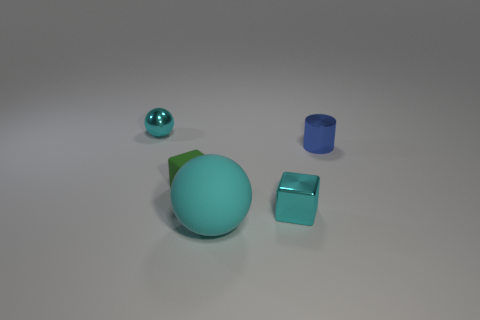Add 1 large cyan spheres. How many objects exist? 6 Subtract all balls. How many objects are left? 3 Subtract 1 cubes. How many cubes are left? 1 Subtract all brown balls. Subtract all brown cylinders. How many balls are left? 2 Subtract all gray cylinders. How many green cubes are left? 1 Subtract all cyan spheres. Subtract all green rubber cubes. How many objects are left? 2 Add 1 tiny blue metal objects. How many tiny blue metal objects are left? 2 Add 3 blue rubber blocks. How many blue rubber blocks exist? 3 Subtract 2 cyan spheres. How many objects are left? 3 